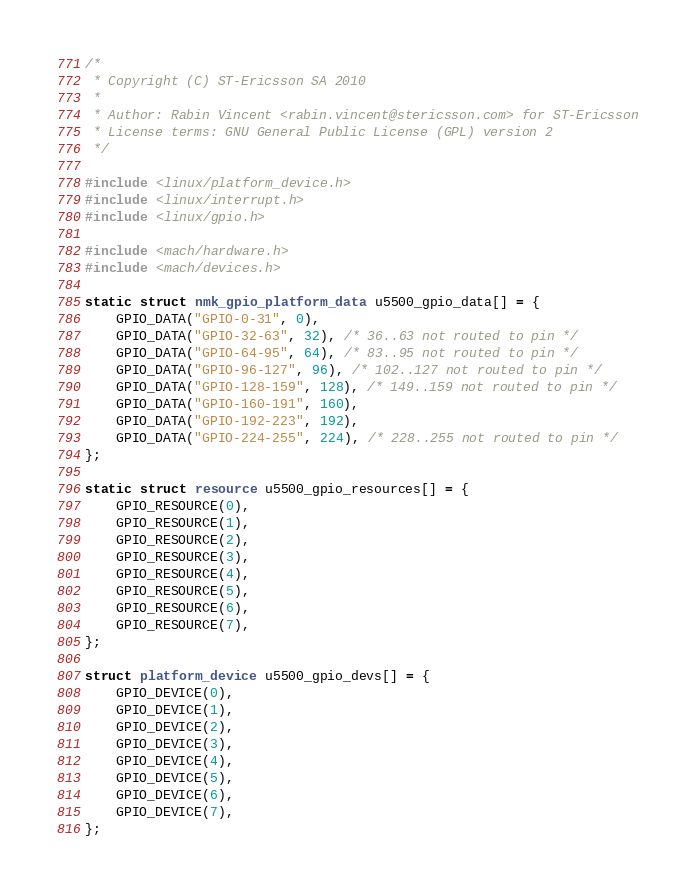<code> <loc_0><loc_0><loc_500><loc_500><_C_>/*
 * Copyright (C) ST-Ericsson SA 2010
 *
 * Author: Rabin Vincent <rabin.vincent@stericsson.com> for ST-Ericsson
 * License terms: GNU General Public License (GPL) version 2
 */

#include <linux/platform_device.h>
#include <linux/interrupt.h>
#include <linux/gpio.h>

#include <mach/hardware.h>
#include <mach/devices.h>

static struct nmk_gpio_platform_data u5500_gpio_data[] = {
	GPIO_DATA("GPIO-0-31", 0),
	GPIO_DATA("GPIO-32-63", 32), /* 36..63 not routed to pin */
	GPIO_DATA("GPIO-64-95", 64), /* 83..95 not routed to pin */
	GPIO_DATA("GPIO-96-127", 96), /* 102..127 not routed to pin */
	GPIO_DATA("GPIO-128-159", 128), /* 149..159 not routed to pin */
	GPIO_DATA("GPIO-160-191", 160),
	GPIO_DATA("GPIO-192-223", 192),
	GPIO_DATA("GPIO-224-255", 224), /* 228..255 not routed to pin */
};

static struct resource u5500_gpio_resources[] = {
	GPIO_RESOURCE(0),
	GPIO_RESOURCE(1),
	GPIO_RESOURCE(2),
	GPIO_RESOURCE(3),
	GPIO_RESOURCE(4),
	GPIO_RESOURCE(5),
	GPIO_RESOURCE(6),
	GPIO_RESOURCE(7),
};

struct platform_device u5500_gpio_devs[] = {
	GPIO_DEVICE(0),
	GPIO_DEVICE(1),
	GPIO_DEVICE(2),
	GPIO_DEVICE(3),
	GPIO_DEVICE(4),
	GPIO_DEVICE(5),
	GPIO_DEVICE(6),
	GPIO_DEVICE(7),
};
</code> 